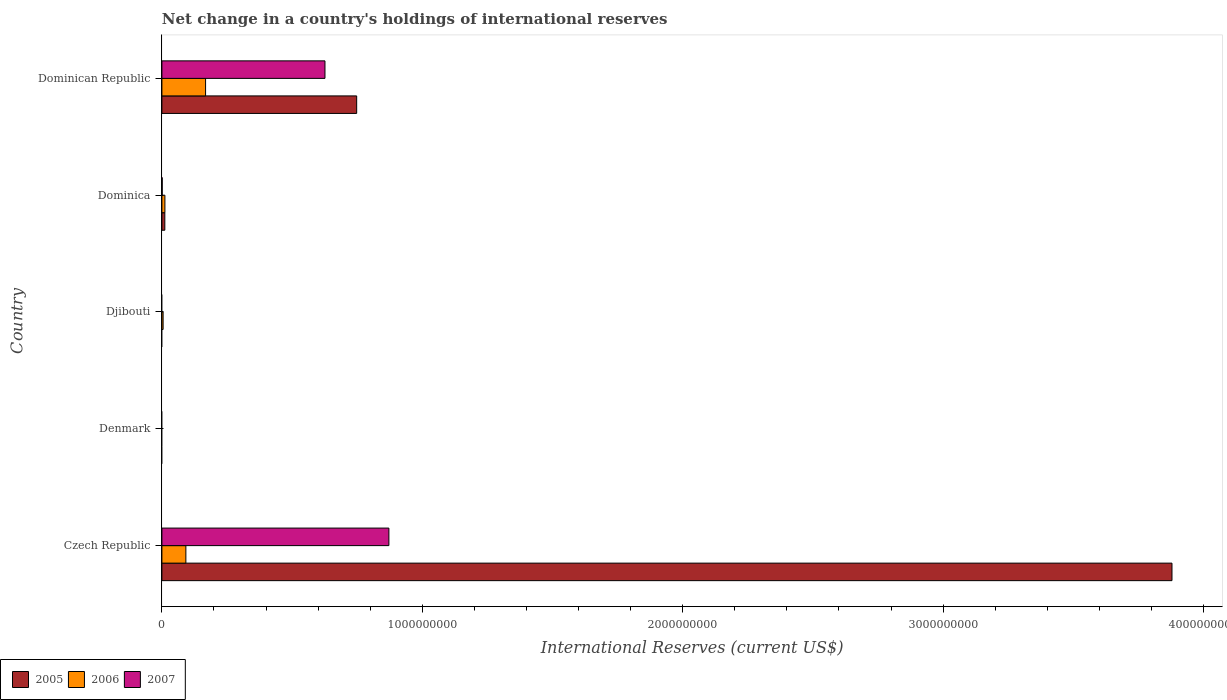What is the label of the 2nd group of bars from the top?
Ensure brevity in your answer.  Dominica. What is the international reserves in 2006 in Djibouti?
Your answer should be compact. 4.65e+06. Across all countries, what is the maximum international reserves in 2005?
Make the answer very short. 3.88e+09. In which country was the international reserves in 2005 maximum?
Offer a terse response. Czech Republic. What is the total international reserves in 2005 in the graph?
Provide a short and direct response. 4.64e+09. What is the difference between the international reserves in 2006 in Dominica and that in Dominican Republic?
Provide a short and direct response. -1.56e+08. What is the difference between the international reserves in 2005 in Dominica and the international reserves in 2006 in Czech Republic?
Your answer should be compact. -8.09e+07. What is the average international reserves in 2005 per country?
Make the answer very short. 9.28e+08. What is the difference between the international reserves in 2007 and international reserves in 2006 in Czech Republic?
Your answer should be compact. 7.80e+08. In how many countries, is the international reserves in 2006 greater than 1800000000 US$?
Offer a terse response. 0. What is the difference between the highest and the second highest international reserves in 2007?
Keep it short and to the point. 2.45e+08. What is the difference between the highest and the lowest international reserves in 2006?
Offer a terse response. 1.68e+08. In how many countries, is the international reserves in 2007 greater than the average international reserves in 2007 taken over all countries?
Your answer should be very brief. 2. Is the sum of the international reserves in 2006 in Djibouti and Dominica greater than the maximum international reserves in 2005 across all countries?
Keep it short and to the point. No. Is it the case that in every country, the sum of the international reserves in 2005 and international reserves in 2007 is greater than the international reserves in 2006?
Offer a terse response. No. How many bars are there?
Keep it short and to the point. 10. Are all the bars in the graph horizontal?
Keep it short and to the point. Yes. How many countries are there in the graph?
Offer a very short reply. 5. Are the values on the major ticks of X-axis written in scientific E-notation?
Your response must be concise. No. Does the graph contain any zero values?
Give a very brief answer. Yes. Does the graph contain grids?
Your response must be concise. No. Where does the legend appear in the graph?
Your answer should be very brief. Bottom left. What is the title of the graph?
Offer a terse response. Net change in a country's holdings of international reserves. Does "1976" appear as one of the legend labels in the graph?
Ensure brevity in your answer.  No. What is the label or title of the X-axis?
Make the answer very short. International Reserves (current US$). What is the International Reserves (current US$) of 2005 in Czech Republic?
Make the answer very short. 3.88e+09. What is the International Reserves (current US$) in 2006 in Czech Republic?
Your answer should be compact. 9.21e+07. What is the International Reserves (current US$) in 2007 in Czech Republic?
Ensure brevity in your answer.  8.72e+08. What is the International Reserves (current US$) in 2006 in Denmark?
Provide a succinct answer. 0. What is the International Reserves (current US$) of 2006 in Djibouti?
Offer a terse response. 4.65e+06. What is the International Reserves (current US$) in 2005 in Dominica?
Ensure brevity in your answer.  1.12e+07. What is the International Reserves (current US$) of 2006 in Dominica?
Your response must be concise. 1.16e+07. What is the International Reserves (current US$) of 2007 in Dominica?
Keep it short and to the point. 1.16e+06. What is the International Reserves (current US$) in 2005 in Dominican Republic?
Keep it short and to the point. 7.48e+08. What is the International Reserves (current US$) in 2006 in Dominican Republic?
Give a very brief answer. 1.68e+08. What is the International Reserves (current US$) in 2007 in Dominican Republic?
Your answer should be very brief. 6.26e+08. Across all countries, what is the maximum International Reserves (current US$) of 2005?
Your answer should be very brief. 3.88e+09. Across all countries, what is the maximum International Reserves (current US$) of 2006?
Give a very brief answer. 1.68e+08. Across all countries, what is the maximum International Reserves (current US$) in 2007?
Your answer should be very brief. 8.72e+08. Across all countries, what is the minimum International Reserves (current US$) of 2005?
Offer a terse response. 0. Across all countries, what is the minimum International Reserves (current US$) in 2006?
Offer a terse response. 0. What is the total International Reserves (current US$) of 2005 in the graph?
Your answer should be compact. 4.64e+09. What is the total International Reserves (current US$) of 2006 in the graph?
Keep it short and to the point. 2.76e+08. What is the total International Reserves (current US$) of 2007 in the graph?
Make the answer very short. 1.50e+09. What is the difference between the International Reserves (current US$) in 2006 in Czech Republic and that in Djibouti?
Give a very brief answer. 8.74e+07. What is the difference between the International Reserves (current US$) of 2005 in Czech Republic and that in Dominica?
Your answer should be compact. 3.87e+09. What is the difference between the International Reserves (current US$) in 2006 in Czech Republic and that in Dominica?
Provide a succinct answer. 8.05e+07. What is the difference between the International Reserves (current US$) in 2007 in Czech Republic and that in Dominica?
Your response must be concise. 8.70e+08. What is the difference between the International Reserves (current US$) in 2005 in Czech Republic and that in Dominican Republic?
Provide a succinct answer. 3.13e+09. What is the difference between the International Reserves (current US$) in 2006 in Czech Republic and that in Dominican Republic?
Make the answer very short. -7.56e+07. What is the difference between the International Reserves (current US$) in 2007 in Czech Republic and that in Dominican Republic?
Give a very brief answer. 2.45e+08. What is the difference between the International Reserves (current US$) of 2006 in Djibouti and that in Dominica?
Your response must be concise. -6.92e+06. What is the difference between the International Reserves (current US$) of 2006 in Djibouti and that in Dominican Republic?
Offer a very short reply. -1.63e+08. What is the difference between the International Reserves (current US$) in 2005 in Dominica and that in Dominican Republic?
Make the answer very short. -7.37e+08. What is the difference between the International Reserves (current US$) of 2006 in Dominica and that in Dominican Republic?
Make the answer very short. -1.56e+08. What is the difference between the International Reserves (current US$) in 2007 in Dominica and that in Dominican Republic?
Ensure brevity in your answer.  -6.25e+08. What is the difference between the International Reserves (current US$) of 2005 in Czech Republic and the International Reserves (current US$) of 2006 in Djibouti?
Provide a short and direct response. 3.87e+09. What is the difference between the International Reserves (current US$) in 2005 in Czech Republic and the International Reserves (current US$) in 2006 in Dominica?
Your response must be concise. 3.87e+09. What is the difference between the International Reserves (current US$) in 2005 in Czech Republic and the International Reserves (current US$) in 2007 in Dominica?
Offer a very short reply. 3.88e+09. What is the difference between the International Reserves (current US$) in 2006 in Czech Republic and the International Reserves (current US$) in 2007 in Dominica?
Keep it short and to the point. 9.09e+07. What is the difference between the International Reserves (current US$) of 2005 in Czech Republic and the International Reserves (current US$) of 2006 in Dominican Republic?
Keep it short and to the point. 3.71e+09. What is the difference between the International Reserves (current US$) in 2005 in Czech Republic and the International Reserves (current US$) in 2007 in Dominican Republic?
Your answer should be very brief. 3.25e+09. What is the difference between the International Reserves (current US$) of 2006 in Czech Republic and the International Reserves (current US$) of 2007 in Dominican Republic?
Your response must be concise. -5.34e+08. What is the difference between the International Reserves (current US$) of 2006 in Djibouti and the International Reserves (current US$) of 2007 in Dominica?
Your answer should be very brief. 3.49e+06. What is the difference between the International Reserves (current US$) in 2006 in Djibouti and the International Reserves (current US$) in 2007 in Dominican Republic?
Offer a very short reply. -6.22e+08. What is the difference between the International Reserves (current US$) in 2005 in Dominica and the International Reserves (current US$) in 2006 in Dominican Republic?
Give a very brief answer. -1.56e+08. What is the difference between the International Reserves (current US$) of 2005 in Dominica and the International Reserves (current US$) of 2007 in Dominican Republic?
Offer a terse response. -6.15e+08. What is the difference between the International Reserves (current US$) of 2006 in Dominica and the International Reserves (current US$) of 2007 in Dominican Republic?
Keep it short and to the point. -6.15e+08. What is the average International Reserves (current US$) of 2005 per country?
Make the answer very short. 9.28e+08. What is the average International Reserves (current US$) of 2006 per country?
Keep it short and to the point. 5.52e+07. What is the average International Reserves (current US$) in 2007 per country?
Ensure brevity in your answer.  3.00e+08. What is the difference between the International Reserves (current US$) of 2005 and International Reserves (current US$) of 2006 in Czech Republic?
Offer a very short reply. 3.79e+09. What is the difference between the International Reserves (current US$) in 2005 and International Reserves (current US$) in 2007 in Czech Republic?
Provide a short and direct response. 3.01e+09. What is the difference between the International Reserves (current US$) of 2006 and International Reserves (current US$) of 2007 in Czech Republic?
Keep it short and to the point. -7.80e+08. What is the difference between the International Reserves (current US$) of 2005 and International Reserves (current US$) of 2006 in Dominica?
Ensure brevity in your answer.  -3.41e+05. What is the difference between the International Reserves (current US$) of 2005 and International Reserves (current US$) of 2007 in Dominica?
Your response must be concise. 1.01e+07. What is the difference between the International Reserves (current US$) of 2006 and International Reserves (current US$) of 2007 in Dominica?
Ensure brevity in your answer.  1.04e+07. What is the difference between the International Reserves (current US$) in 2005 and International Reserves (current US$) in 2006 in Dominican Republic?
Your answer should be very brief. 5.80e+08. What is the difference between the International Reserves (current US$) of 2005 and International Reserves (current US$) of 2007 in Dominican Republic?
Provide a succinct answer. 1.22e+08. What is the difference between the International Reserves (current US$) of 2006 and International Reserves (current US$) of 2007 in Dominican Republic?
Ensure brevity in your answer.  -4.58e+08. What is the ratio of the International Reserves (current US$) in 2006 in Czech Republic to that in Djibouti?
Ensure brevity in your answer.  19.8. What is the ratio of the International Reserves (current US$) in 2005 in Czech Republic to that in Dominica?
Offer a very short reply. 345.45. What is the ratio of the International Reserves (current US$) in 2006 in Czech Republic to that in Dominica?
Your response must be concise. 7.96. What is the ratio of the International Reserves (current US$) in 2007 in Czech Republic to that in Dominica?
Make the answer very short. 748.74. What is the ratio of the International Reserves (current US$) in 2005 in Czech Republic to that in Dominican Republic?
Your answer should be very brief. 5.19. What is the ratio of the International Reserves (current US$) in 2006 in Czech Republic to that in Dominican Republic?
Make the answer very short. 0.55. What is the ratio of the International Reserves (current US$) in 2007 in Czech Republic to that in Dominican Republic?
Offer a very short reply. 1.39. What is the ratio of the International Reserves (current US$) of 2006 in Djibouti to that in Dominica?
Keep it short and to the point. 0.4. What is the ratio of the International Reserves (current US$) in 2006 in Djibouti to that in Dominican Republic?
Ensure brevity in your answer.  0.03. What is the ratio of the International Reserves (current US$) in 2005 in Dominica to that in Dominican Republic?
Provide a short and direct response. 0.01. What is the ratio of the International Reserves (current US$) of 2006 in Dominica to that in Dominican Republic?
Give a very brief answer. 0.07. What is the ratio of the International Reserves (current US$) in 2007 in Dominica to that in Dominican Republic?
Your answer should be very brief. 0. What is the difference between the highest and the second highest International Reserves (current US$) in 2005?
Offer a very short reply. 3.13e+09. What is the difference between the highest and the second highest International Reserves (current US$) in 2006?
Ensure brevity in your answer.  7.56e+07. What is the difference between the highest and the second highest International Reserves (current US$) of 2007?
Your answer should be very brief. 2.45e+08. What is the difference between the highest and the lowest International Reserves (current US$) in 2005?
Give a very brief answer. 3.88e+09. What is the difference between the highest and the lowest International Reserves (current US$) of 2006?
Offer a terse response. 1.68e+08. What is the difference between the highest and the lowest International Reserves (current US$) of 2007?
Your response must be concise. 8.72e+08. 